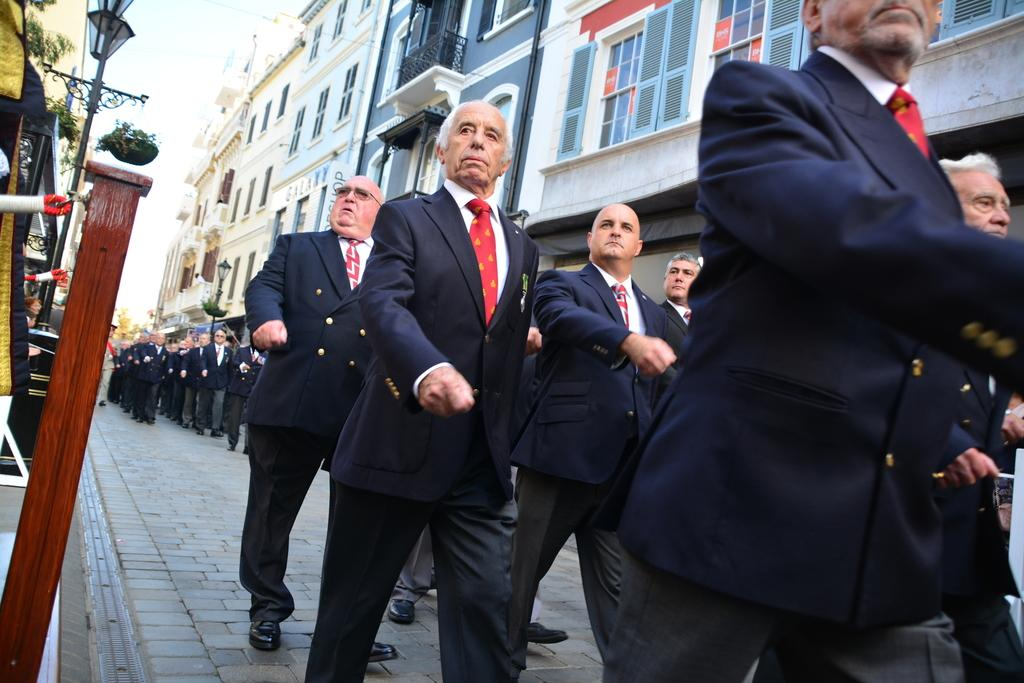What is the main subject of the image? The main subject of the image is men in the center of the image. What are the men doing in the image? The men are walking in series in the image. What can be seen in the background of the image? There are buildings at the top side of the image. What type of cream can be seen on the men's faces in the image? There is no cream visible on the men's faces in the image. How are the men transporting themselves in the image? The facts do not mention any form of transportation; the men are walking on their own. 